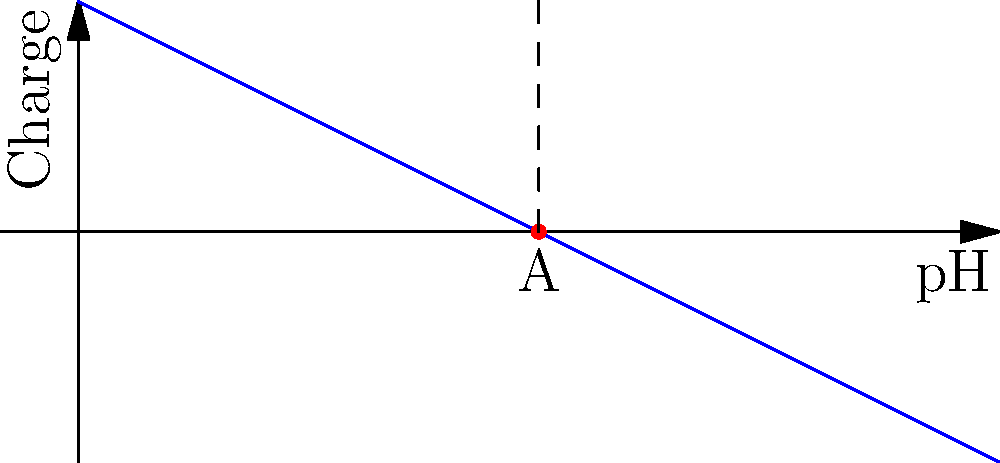In the pH vs. charge graph shown above for a hypothetical protein, point A represents the isoelectric point. What is the approximate pH value at the isoelectric point of this protein? To determine the isoelectric point (pI) of a protein from a pH vs. charge graph, we need to follow these steps:

1. Understand that the isoelectric point is the pH at which the protein has no net electrical charge.

2. On the graph, this corresponds to the point where the charge is zero.

3. Identify point A on the graph, which is labeled as the isoelectric point.

4. Observe that point A is located on the x-axis (charge = 0).

5. Read the pH value corresponding to point A by projecting it onto the x-axis.

6. We can see that the dashed line from point A intersects the x-axis at a pH value of 4.

Therefore, the approximate pH value at the isoelectric point of this protein is 4.
Answer: 4 